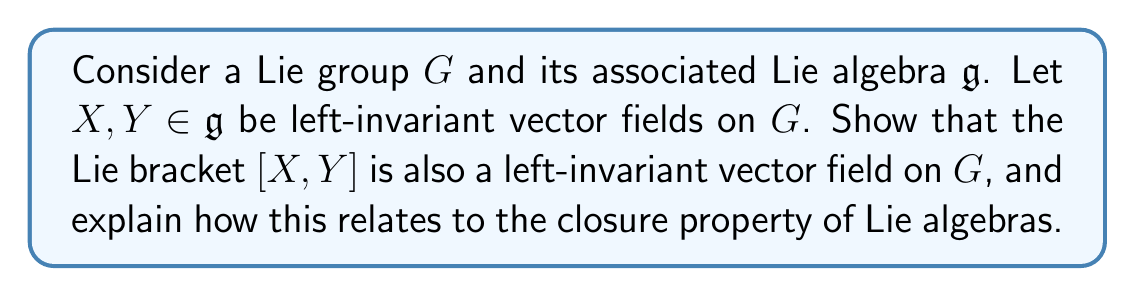Can you answer this question? To prove that the Lie bracket $[X,Y]$ is a left-invariant vector field on $G$, we need to follow these steps:

1) First, recall that for any smooth manifold $M$, the Lie bracket of two vector fields $X$ and $Y$ is defined as:

   $$[X,Y](f) = X(Y(f)) - Y(X(f))$$

   where $f$ is any smooth function on $M$.

2) Now, let's consider the left translation map $L_g: G \rightarrow G$ for any $g \in G$, defined by $L_g(h) = gh$ for all $h \in G$.

3) For $X$ and $Y$ to be left-invariant, they must satisfy:

   $$(dL_g)_h(X_h) = X_{gh}$$
   $$(dL_g)_h(Y_h) = Y_{gh}$$

   for all $g, h \in G$, where $(dL_g)_h$ is the differential of $L_g$ at $h$.

4) To show that $[X,Y]$ is left-invariant, we need to prove:

   $$(dL_g)_h([X,Y]_h) = [X,Y]_{gh}$$

5) Let $f$ be any smooth function on $G$. We can write:

   $$\begin{align*}
   (dL_g)_h([X,Y]_h)(f) &= [X,Y]_h(f \circ L_g) \\
   &= X_h(Y(f \circ L_g)) - Y_h(X(f \circ L_g)) \\
   &= X_h((f \circ L_g \circ L_h) \circ Y) - Y_h((f \circ L_g \circ L_h) \circ X) \\
   &= X_{gh}(f \circ Y) - Y_{gh}(f \circ X) \\
   &= [X,Y]_{gh}(f)
   \end{align*}$$

6) This proves that $[X,Y]$ is indeed a left-invariant vector field on $G$.

7) The closure property of Lie algebras states that the Lie bracket of any two elements in a Lie algebra must also be an element of that Lie algebra. In this case, we've shown that the Lie bracket of two left-invariant vector fields (which are elements of the Lie algebra $\mathfrak{g}$) is also a left-invariant vector field, and thus an element of $\mathfrak{g}$.

This result demonstrates the fundamental connection between Lie groups and their associated Lie algebras: the algebraic structure of the Lie algebra (given by the Lie bracket) directly corresponds to the geometric structure of the Lie group (given by left-invariant vector fields).
Answer: The Lie bracket $[X,Y]$ of two left-invariant vector fields $X$ and $Y$ on a Lie group $G$ is also a left-invariant vector field on $G$. This result confirms the closure property of the Lie algebra $\mathfrak{g}$ associated with $G$ under the Lie bracket operation. 